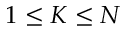Convert formula to latex. <formula><loc_0><loc_0><loc_500><loc_500>1 \leq K \leq N</formula> 